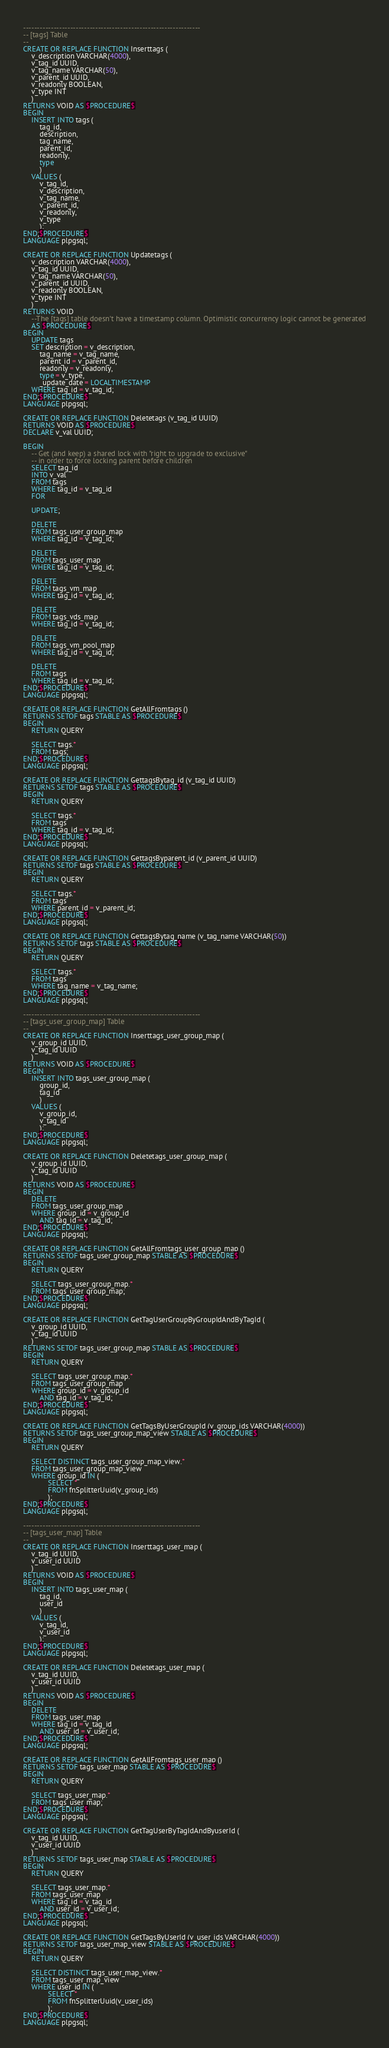Convert code to text. <code><loc_0><loc_0><loc_500><loc_500><_SQL_>

----------------------------------------------------------------
-- [tags] Table
--
CREATE OR REPLACE FUNCTION Inserttags (
    v_description VARCHAR(4000),
    v_tag_id UUID,
    v_tag_name VARCHAR(50),
    v_parent_id UUID,
    v_readonly BOOLEAN,
    v_type INT
    )
RETURNS VOID AS $PROCEDURE$
BEGIN
    INSERT INTO tags (
        tag_id,
        description,
        tag_name,
        parent_id,
        readonly,
        type
        )
    VALUES (
        v_tag_id,
        v_description,
        v_tag_name,
        v_parent_id,
        v_readonly,
        v_type
        );
END;$PROCEDURE$
LANGUAGE plpgsql;

CREATE OR REPLACE FUNCTION Updatetags (
    v_description VARCHAR(4000),
    v_tag_id UUID,
    v_tag_name VARCHAR(50),
    v_parent_id UUID,
    v_readonly BOOLEAN,
    v_type INT
    )
RETURNS VOID
    --The [tags] table doesn't have a timestamp column. Optimistic concurrency logic cannot be generated
    AS $PROCEDURE$
BEGIN
    UPDATE tags
    SET description = v_description,
        tag_name = v_tag_name,
        parent_id = v_parent_id,
        readonly = v_readonly,
        type = v_type,
        _update_date = LOCALTIMESTAMP
    WHERE tag_id = v_tag_id;
END;$PROCEDURE$
LANGUAGE plpgsql;

CREATE OR REPLACE FUNCTION Deletetags (v_tag_id UUID)
RETURNS VOID AS $PROCEDURE$
DECLARE v_val UUID;

BEGIN
    -- Get (and keep) a shared lock with "right to upgrade to exclusive"
    -- in order to force locking parent before children
    SELECT tag_id
    INTO v_val
    FROM tags
    WHERE tag_id = v_tag_id
    FOR

    UPDATE;

    DELETE
    FROM tags_user_group_map
    WHERE tag_id = v_tag_id;

    DELETE
    FROM tags_user_map
    WHERE tag_id = v_tag_id;

    DELETE
    FROM tags_vm_map
    WHERE tag_id = v_tag_id;

    DELETE
    FROM tags_vds_map
    WHERE tag_id = v_tag_id;

    DELETE
    FROM tags_vm_pool_map
    WHERE tag_id = v_tag_id;

    DELETE
    FROM tags
    WHERE tag_id = v_tag_id;
END;$PROCEDURE$
LANGUAGE plpgsql;

CREATE OR REPLACE FUNCTION GetAllFromtags ()
RETURNS SETOF tags STABLE AS $PROCEDURE$
BEGIN
    RETURN QUERY

    SELECT tags.*
    FROM tags;
END;$PROCEDURE$
LANGUAGE plpgsql;

CREATE OR REPLACE FUNCTION GettagsBytag_id (v_tag_id UUID)
RETURNS SETOF tags STABLE AS $PROCEDURE$
BEGIN
    RETURN QUERY

    SELECT tags.*
    FROM tags
    WHERE tag_id = v_tag_id;
END;$PROCEDURE$
LANGUAGE plpgsql;

CREATE OR REPLACE FUNCTION GettagsByparent_id (v_parent_id UUID)
RETURNS SETOF tags STABLE AS $PROCEDURE$
BEGIN
    RETURN QUERY

    SELECT tags.*
    FROM tags
    WHERE parent_id = v_parent_id;
END;$PROCEDURE$
LANGUAGE plpgsql;

CREATE OR REPLACE FUNCTION GettagsBytag_name (v_tag_name VARCHAR(50))
RETURNS SETOF tags STABLE AS $PROCEDURE$
BEGIN
    RETURN QUERY

    SELECT tags.*
    FROM tags
    WHERE tag_name = v_tag_name;
END;$PROCEDURE$
LANGUAGE plpgsql;

----------------------------------------------------------------
-- [tags_user_group_map] Table
--
CREATE OR REPLACE FUNCTION Inserttags_user_group_map (
    v_group_id UUID,
    v_tag_id UUID
    )
RETURNS VOID AS $PROCEDURE$
BEGIN
    INSERT INTO tags_user_group_map (
        group_id,
        tag_id
        )
    VALUES (
        v_group_id,
        v_tag_id
        );
END;$PROCEDURE$
LANGUAGE plpgsql;

CREATE OR REPLACE FUNCTION Deletetags_user_group_map (
    v_group_id UUID,
    v_tag_id UUID
    )
RETURNS VOID AS $PROCEDURE$
BEGIN
    DELETE
    FROM tags_user_group_map
    WHERE group_id = v_group_id
        AND tag_id = v_tag_id;
END;$PROCEDURE$
LANGUAGE plpgsql;

CREATE OR REPLACE FUNCTION GetAllFromtags_user_group_map ()
RETURNS SETOF tags_user_group_map STABLE AS $PROCEDURE$
BEGIN
    RETURN QUERY

    SELECT tags_user_group_map.*
    FROM tags_user_group_map;
END;$PROCEDURE$
LANGUAGE plpgsql;

CREATE OR REPLACE FUNCTION GetTagUserGroupByGroupIdAndByTagId (
    v_group_id UUID,
    v_tag_id UUID
    )
RETURNS SETOF tags_user_group_map STABLE AS $PROCEDURE$
BEGIN
    RETURN QUERY

    SELECT tags_user_group_map.*
    FROM tags_user_group_map
    WHERE group_id = v_group_id
        AND tag_id = v_tag_id;
END;$PROCEDURE$
LANGUAGE plpgsql;

CREATE OR REPLACE FUNCTION GetTagsByUserGroupId (v_group_ids VARCHAR(4000))
RETURNS SETOF tags_user_group_map_view STABLE AS $PROCEDURE$
BEGIN
    RETURN QUERY

    SELECT DISTINCT tags_user_group_map_view.*
    FROM tags_user_group_map_view
    WHERE group_id IN (
            SELECT *
            FROM fnSplitterUuid(v_group_ids)
            );
END;$PROCEDURE$
LANGUAGE plpgsql;

----------------------------------------------------------------
-- [tags_user_map] Table
--
CREATE OR REPLACE FUNCTION Inserttags_user_map (
    v_tag_id UUID,
    v_user_id UUID
    )
RETURNS VOID AS $PROCEDURE$
BEGIN
    INSERT INTO tags_user_map (
        tag_id,
        user_id
        )
    VALUES (
        v_tag_id,
        v_user_id
        );
END;$PROCEDURE$
LANGUAGE plpgsql;

CREATE OR REPLACE FUNCTION Deletetags_user_map (
    v_tag_id UUID,
    v_user_id UUID
    )
RETURNS VOID AS $PROCEDURE$
BEGIN
    DELETE
    FROM tags_user_map
    WHERE tag_id = v_tag_id
        AND user_id = v_user_id;
END;$PROCEDURE$
LANGUAGE plpgsql;

CREATE OR REPLACE FUNCTION GetAllFromtags_user_map ()
RETURNS SETOF tags_user_map STABLE AS $PROCEDURE$
BEGIN
    RETURN QUERY

    SELECT tags_user_map.*
    FROM tags_user_map;
END;$PROCEDURE$
LANGUAGE plpgsql;

CREATE OR REPLACE FUNCTION GetTagUserByTagIdAndByuserId (
    v_tag_id UUID,
    v_user_id UUID
    )
RETURNS SETOF tags_user_map STABLE AS $PROCEDURE$
BEGIN
    RETURN QUERY

    SELECT tags_user_map.*
    FROM tags_user_map
    WHERE tag_id = v_tag_id
        AND user_id = v_user_id;
END;$PROCEDURE$
LANGUAGE plpgsql;

CREATE OR REPLACE FUNCTION GetTagsByUserId (v_user_ids VARCHAR(4000))
RETURNS SETOF tags_user_map_view STABLE AS $PROCEDURE$
BEGIN
    RETURN QUERY

    SELECT DISTINCT tags_user_map_view.*
    FROM tags_user_map_view
    WHERE user_id IN (
            SELECT *
            FROM fnSplitterUuid(v_user_ids)
            );
END;$PROCEDURE$
LANGUAGE plpgsql;
</code> 